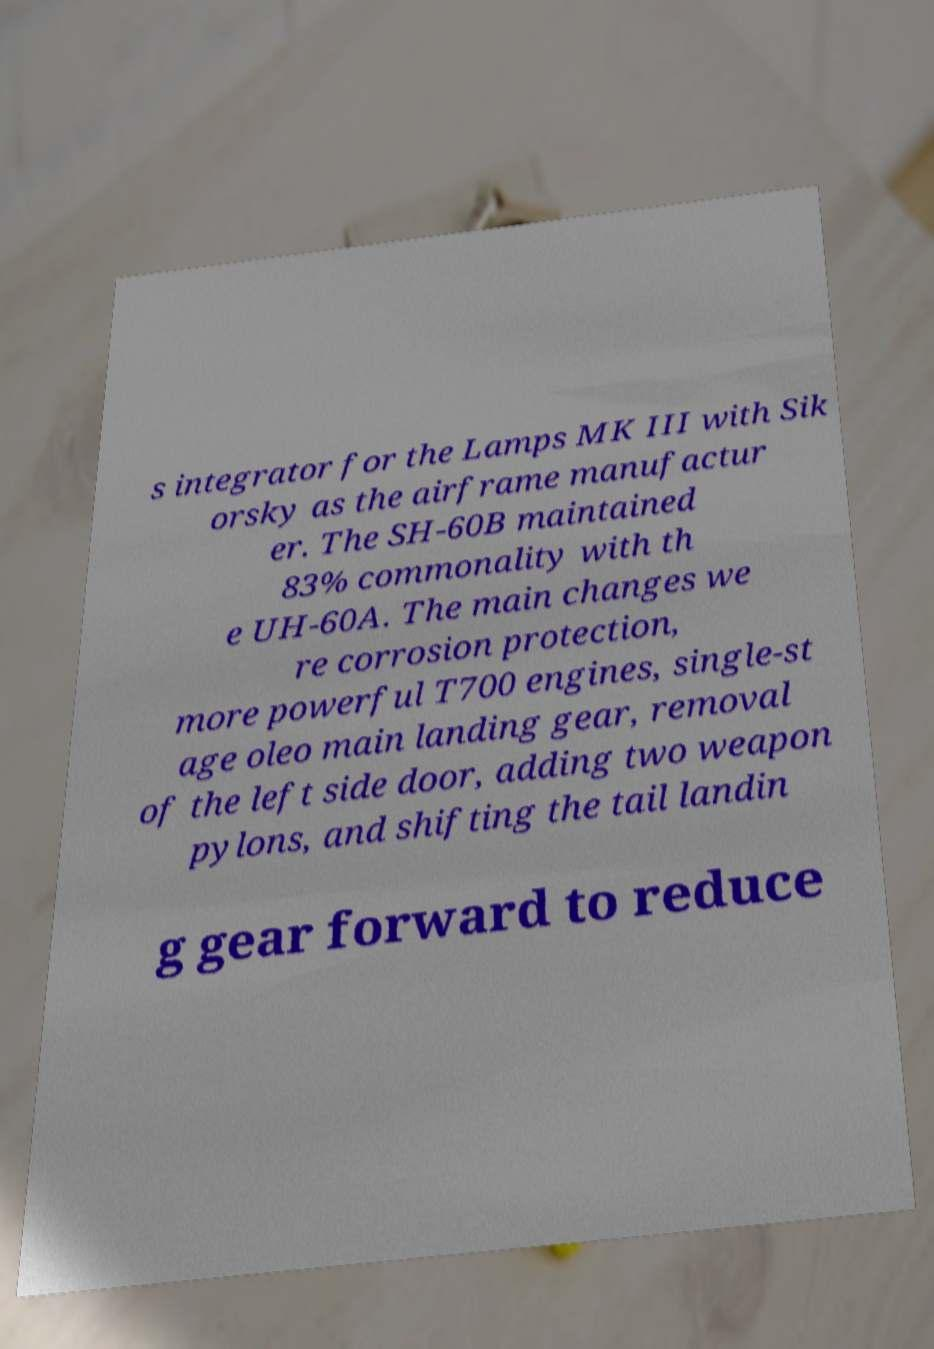There's text embedded in this image that I need extracted. Can you transcribe it verbatim? s integrator for the Lamps MK III with Sik orsky as the airframe manufactur er. The SH-60B maintained 83% commonality with th e UH-60A. The main changes we re corrosion protection, more powerful T700 engines, single-st age oleo main landing gear, removal of the left side door, adding two weapon pylons, and shifting the tail landin g gear forward to reduce 